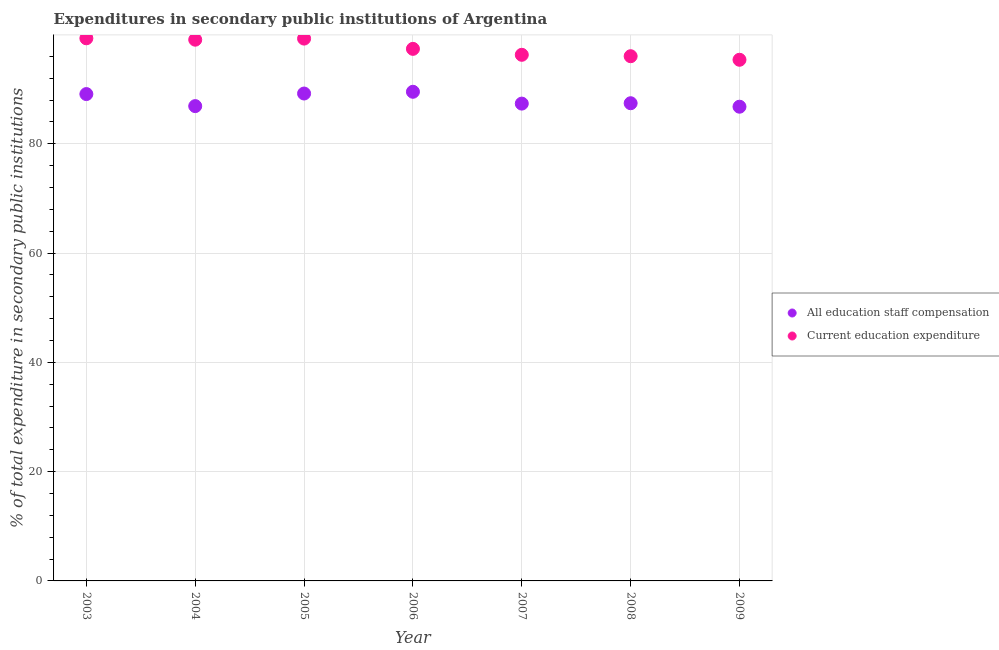How many different coloured dotlines are there?
Provide a short and direct response. 2. What is the expenditure in education in 2003?
Offer a very short reply. 99.31. Across all years, what is the maximum expenditure in staff compensation?
Your response must be concise. 89.52. Across all years, what is the minimum expenditure in education?
Make the answer very short. 95.38. What is the total expenditure in education in the graph?
Ensure brevity in your answer.  682.71. What is the difference between the expenditure in education in 2008 and that in 2009?
Your response must be concise. 0.65. What is the difference between the expenditure in staff compensation in 2003 and the expenditure in education in 2009?
Your answer should be very brief. -6.28. What is the average expenditure in staff compensation per year?
Offer a very short reply. 88.04. In the year 2005, what is the difference between the expenditure in staff compensation and expenditure in education?
Provide a short and direct response. -10.05. What is the ratio of the expenditure in staff compensation in 2005 to that in 2008?
Provide a short and direct response. 1.02. Is the difference between the expenditure in staff compensation in 2004 and 2007 greater than the difference between the expenditure in education in 2004 and 2007?
Your answer should be compact. No. What is the difference between the highest and the second highest expenditure in education?
Provide a succinct answer. 0.05. What is the difference between the highest and the lowest expenditure in staff compensation?
Keep it short and to the point. 2.73. Is the expenditure in education strictly greater than the expenditure in staff compensation over the years?
Offer a very short reply. Yes. Is the expenditure in staff compensation strictly less than the expenditure in education over the years?
Keep it short and to the point. Yes. How many dotlines are there?
Your answer should be very brief. 2. Are the values on the major ticks of Y-axis written in scientific E-notation?
Give a very brief answer. No. How are the legend labels stacked?
Your answer should be compact. Vertical. What is the title of the graph?
Offer a very short reply. Expenditures in secondary public institutions of Argentina. Does "Chemicals" appear as one of the legend labels in the graph?
Provide a short and direct response. No. What is the label or title of the X-axis?
Provide a short and direct response. Year. What is the label or title of the Y-axis?
Provide a short and direct response. % of total expenditure in secondary public institutions. What is the % of total expenditure in secondary public institutions in All education staff compensation in 2003?
Keep it short and to the point. 89.1. What is the % of total expenditure in secondary public institutions of Current education expenditure in 2003?
Your answer should be compact. 99.31. What is the % of total expenditure in secondary public institutions of All education staff compensation in 2004?
Keep it short and to the point. 86.9. What is the % of total expenditure in secondary public institutions in Current education expenditure in 2004?
Ensure brevity in your answer.  99.06. What is the % of total expenditure in secondary public institutions of All education staff compensation in 2005?
Make the answer very short. 89.2. What is the % of total expenditure in secondary public institutions in Current education expenditure in 2005?
Your response must be concise. 99.26. What is the % of total expenditure in secondary public institutions in All education staff compensation in 2006?
Your response must be concise. 89.52. What is the % of total expenditure in secondary public institutions in Current education expenditure in 2006?
Provide a short and direct response. 97.38. What is the % of total expenditure in secondary public institutions of All education staff compensation in 2007?
Offer a very short reply. 87.36. What is the % of total expenditure in secondary public institutions of Current education expenditure in 2007?
Keep it short and to the point. 96.29. What is the % of total expenditure in secondary public institutions in All education staff compensation in 2008?
Offer a terse response. 87.43. What is the % of total expenditure in secondary public institutions in Current education expenditure in 2008?
Your response must be concise. 96.03. What is the % of total expenditure in secondary public institutions in All education staff compensation in 2009?
Give a very brief answer. 86.79. What is the % of total expenditure in secondary public institutions of Current education expenditure in 2009?
Provide a short and direct response. 95.38. Across all years, what is the maximum % of total expenditure in secondary public institutions in All education staff compensation?
Give a very brief answer. 89.52. Across all years, what is the maximum % of total expenditure in secondary public institutions of Current education expenditure?
Make the answer very short. 99.31. Across all years, what is the minimum % of total expenditure in secondary public institutions of All education staff compensation?
Give a very brief answer. 86.79. Across all years, what is the minimum % of total expenditure in secondary public institutions in Current education expenditure?
Offer a very short reply. 95.38. What is the total % of total expenditure in secondary public institutions in All education staff compensation in the graph?
Ensure brevity in your answer.  616.31. What is the total % of total expenditure in secondary public institutions of Current education expenditure in the graph?
Make the answer very short. 682.71. What is the difference between the % of total expenditure in secondary public institutions of All education staff compensation in 2003 and that in 2004?
Offer a terse response. 2.2. What is the difference between the % of total expenditure in secondary public institutions of Current education expenditure in 2003 and that in 2004?
Offer a very short reply. 0.26. What is the difference between the % of total expenditure in secondary public institutions in All education staff compensation in 2003 and that in 2005?
Your answer should be compact. -0.1. What is the difference between the % of total expenditure in secondary public institutions in Current education expenditure in 2003 and that in 2005?
Provide a short and direct response. 0.05. What is the difference between the % of total expenditure in secondary public institutions of All education staff compensation in 2003 and that in 2006?
Provide a short and direct response. -0.42. What is the difference between the % of total expenditure in secondary public institutions of Current education expenditure in 2003 and that in 2006?
Your response must be concise. 1.93. What is the difference between the % of total expenditure in secondary public institutions of All education staff compensation in 2003 and that in 2007?
Ensure brevity in your answer.  1.75. What is the difference between the % of total expenditure in secondary public institutions of Current education expenditure in 2003 and that in 2007?
Ensure brevity in your answer.  3.02. What is the difference between the % of total expenditure in secondary public institutions in All education staff compensation in 2003 and that in 2008?
Your answer should be very brief. 1.68. What is the difference between the % of total expenditure in secondary public institutions in Current education expenditure in 2003 and that in 2008?
Provide a short and direct response. 3.28. What is the difference between the % of total expenditure in secondary public institutions of All education staff compensation in 2003 and that in 2009?
Make the answer very short. 2.31. What is the difference between the % of total expenditure in secondary public institutions in Current education expenditure in 2003 and that in 2009?
Your answer should be compact. 3.93. What is the difference between the % of total expenditure in secondary public institutions in All education staff compensation in 2004 and that in 2005?
Your response must be concise. -2.3. What is the difference between the % of total expenditure in secondary public institutions of Current education expenditure in 2004 and that in 2005?
Keep it short and to the point. -0.2. What is the difference between the % of total expenditure in secondary public institutions in All education staff compensation in 2004 and that in 2006?
Your response must be concise. -2.62. What is the difference between the % of total expenditure in secondary public institutions in Current education expenditure in 2004 and that in 2006?
Offer a very short reply. 1.68. What is the difference between the % of total expenditure in secondary public institutions in All education staff compensation in 2004 and that in 2007?
Make the answer very short. -0.46. What is the difference between the % of total expenditure in secondary public institutions of Current education expenditure in 2004 and that in 2007?
Give a very brief answer. 2.77. What is the difference between the % of total expenditure in secondary public institutions in All education staff compensation in 2004 and that in 2008?
Make the answer very short. -0.53. What is the difference between the % of total expenditure in secondary public institutions of Current education expenditure in 2004 and that in 2008?
Your answer should be compact. 3.02. What is the difference between the % of total expenditure in secondary public institutions in All education staff compensation in 2004 and that in 2009?
Your answer should be very brief. 0.11. What is the difference between the % of total expenditure in secondary public institutions of Current education expenditure in 2004 and that in 2009?
Offer a very short reply. 3.67. What is the difference between the % of total expenditure in secondary public institutions in All education staff compensation in 2005 and that in 2006?
Keep it short and to the point. -0.32. What is the difference between the % of total expenditure in secondary public institutions of Current education expenditure in 2005 and that in 2006?
Offer a very short reply. 1.88. What is the difference between the % of total expenditure in secondary public institutions in All education staff compensation in 2005 and that in 2007?
Offer a terse response. 1.85. What is the difference between the % of total expenditure in secondary public institutions in Current education expenditure in 2005 and that in 2007?
Provide a succinct answer. 2.97. What is the difference between the % of total expenditure in secondary public institutions of All education staff compensation in 2005 and that in 2008?
Provide a short and direct response. 1.78. What is the difference between the % of total expenditure in secondary public institutions of Current education expenditure in 2005 and that in 2008?
Make the answer very short. 3.23. What is the difference between the % of total expenditure in secondary public institutions of All education staff compensation in 2005 and that in 2009?
Provide a short and direct response. 2.41. What is the difference between the % of total expenditure in secondary public institutions of Current education expenditure in 2005 and that in 2009?
Ensure brevity in your answer.  3.88. What is the difference between the % of total expenditure in secondary public institutions of All education staff compensation in 2006 and that in 2007?
Give a very brief answer. 2.16. What is the difference between the % of total expenditure in secondary public institutions in Current education expenditure in 2006 and that in 2007?
Keep it short and to the point. 1.09. What is the difference between the % of total expenditure in secondary public institutions of All education staff compensation in 2006 and that in 2008?
Offer a very short reply. 2.1. What is the difference between the % of total expenditure in secondary public institutions in Current education expenditure in 2006 and that in 2008?
Offer a terse response. 1.35. What is the difference between the % of total expenditure in secondary public institutions of All education staff compensation in 2006 and that in 2009?
Make the answer very short. 2.73. What is the difference between the % of total expenditure in secondary public institutions of Current education expenditure in 2006 and that in 2009?
Keep it short and to the point. 2. What is the difference between the % of total expenditure in secondary public institutions in All education staff compensation in 2007 and that in 2008?
Your answer should be compact. -0.07. What is the difference between the % of total expenditure in secondary public institutions of Current education expenditure in 2007 and that in 2008?
Keep it short and to the point. 0.26. What is the difference between the % of total expenditure in secondary public institutions of All education staff compensation in 2007 and that in 2009?
Offer a very short reply. 0.57. What is the difference between the % of total expenditure in secondary public institutions of Current education expenditure in 2007 and that in 2009?
Ensure brevity in your answer.  0.91. What is the difference between the % of total expenditure in secondary public institutions of All education staff compensation in 2008 and that in 2009?
Offer a very short reply. 0.64. What is the difference between the % of total expenditure in secondary public institutions of Current education expenditure in 2008 and that in 2009?
Provide a succinct answer. 0.65. What is the difference between the % of total expenditure in secondary public institutions in All education staff compensation in 2003 and the % of total expenditure in secondary public institutions in Current education expenditure in 2004?
Your answer should be compact. -9.95. What is the difference between the % of total expenditure in secondary public institutions of All education staff compensation in 2003 and the % of total expenditure in secondary public institutions of Current education expenditure in 2005?
Provide a succinct answer. -10.15. What is the difference between the % of total expenditure in secondary public institutions in All education staff compensation in 2003 and the % of total expenditure in secondary public institutions in Current education expenditure in 2006?
Offer a terse response. -8.27. What is the difference between the % of total expenditure in secondary public institutions of All education staff compensation in 2003 and the % of total expenditure in secondary public institutions of Current education expenditure in 2007?
Your answer should be compact. -7.19. What is the difference between the % of total expenditure in secondary public institutions in All education staff compensation in 2003 and the % of total expenditure in secondary public institutions in Current education expenditure in 2008?
Provide a short and direct response. -6.93. What is the difference between the % of total expenditure in secondary public institutions of All education staff compensation in 2003 and the % of total expenditure in secondary public institutions of Current education expenditure in 2009?
Make the answer very short. -6.28. What is the difference between the % of total expenditure in secondary public institutions in All education staff compensation in 2004 and the % of total expenditure in secondary public institutions in Current education expenditure in 2005?
Give a very brief answer. -12.36. What is the difference between the % of total expenditure in secondary public institutions in All education staff compensation in 2004 and the % of total expenditure in secondary public institutions in Current education expenditure in 2006?
Make the answer very short. -10.48. What is the difference between the % of total expenditure in secondary public institutions of All education staff compensation in 2004 and the % of total expenditure in secondary public institutions of Current education expenditure in 2007?
Keep it short and to the point. -9.39. What is the difference between the % of total expenditure in secondary public institutions in All education staff compensation in 2004 and the % of total expenditure in secondary public institutions in Current education expenditure in 2008?
Offer a very short reply. -9.13. What is the difference between the % of total expenditure in secondary public institutions of All education staff compensation in 2004 and the % of total expenditure in secondary public institutions of Current education expenditure in 2009?
Give a very brief answer. -8.48. What is the difference between the % of total expenditure in secondary public institutions of All education staff compensation in 2005 and the % of total expenditure in secondary public institutions of Current education expenditure in 2006?
Provide a succinct answer. -8.17. What is the difference between the % of total expenditure in secondary public institutions of All education staff compensation in 2005 and the % of total expenditure in secondary public institutions of Current education expenditure in 2007?
Offer a very short reply. -7.09. What is the difference between the % of total expenditure in secondary public institutions of All education staff compensation in 2005 and the % of total expenditure in secondary public institutions of Current education expenditure in 2008?
Your answer should be compact. -6.83. What is the difference between the % of total expenditure in secondary public institutions in All education staff compensation in 2005 and the % of total expenditure in secondary public institutions in Current education expenditure in 2009?
Offer a very short reply. -6.18. What is the difference between the % of total expenditure in secondary public institutions of All education staff compensation in 2006 and the % of total expenditure in secondary public institutions of Current education expenditure in 2007?
Offer a terse response. -6.77. What is the difference between the % of total expenditure in secondary public institutions in All education staff compensation in 2006 and the % of total expenditure in secondary public institutions in Current education expenditure in 2008?
Your response must be concise. -6.51. What is the difference between the % of total expenditure in secondary public institutions in All education staff compensation in 2006 and the % of total expenditure in secondary public institutions in Current education expenditure in 2009?
Ensure brevity in your answer.  -5.86. What is the difference between the % of total expenditure in secondary public institutions of All education staff compensation in 2007 and the % of total expenditure in secondary public institutions of Current education expenditure in 2008?
Provide a succinct answer. -8.67. What is the difference between the % of total expenditure in secondary public institutions in All education staff compensation in 2007 and the % of total expenditure in secondary public institutions in Current education expenditure in 2009?
Give a very brief answer. -8.02. What is the difference between the % of total expenditure in secondary public institutions of All education staff compensation in 2008 and the % of total expenditure in secondary public institutions of Current education expenditure in 2009?
Your answer should be compact. -7.96. What is the average % of total expenditure in secondary public institutions in All education staff compensation per year?
Keep it short and to the point. 88.04. What is the average % of total expenditure in secondary public institutions in Current education expenditure per year?
Keep it short and to the point. 97.53. In the year 2003, what is the difference between the % of total expenditure in secondary public institutions of All education staff compensation and % of total expenditure in secondary public institutions of Current education expenditure?
Your answer should be very brief. -10.21. In the year 2004, what is the difference between the % of total expenditure in secondary public institutions of All education staff compensation and % of total expenditure in secondary public institutions of Current education expenditure?
Ensure brevity in your answer.  -12.16. In the year 2005, what is the difference between the % of total expenditure in secondary public institutions of All education staff compensation and % of total expenditure in secondary public institutions of Current education expenditure?
Give a very brief answer. -10.05. In the year 2006, what is the difference between the % of total expenditure in secondary public institutions of All education staff compensation and % of total expenditure in secondary public institutions of Current education expenditure?
Keep it short and to the point. -7.86. In the year 2007, what is the difference between the % of total expenditure in secondary public institutions of All education staff compensation and % of total expenditure in secondary public institutions of Current education expenditure?
Your answer should be very brief. -8.93. In the year 2008, what is the difference between the % of total expenditure in secondary public institutions of All education staff compensation and % of total expenditure in secondary public institutions of Current education expenditure?
Your answer should be compact. -8.61. In the year 2009, what is the difference between the % of total expenditure in secondary public institutions of All education staff compensation and % of total expenditure in secondary public institutions of Current education expenditure?
Provide a succinct answer. -8.59. What is the ratio of the % of total expenditure in secondary public institutions in All education staff compensation in 2003 to that in 2004?
Offer a terse response. 1.03. What is the ratio of the % of total expenditure in secondary public institutions of All education staff compensation in 2003 to that in 2005?
Provide a succinct answer. 1. What is the ratio of the % of total expenditure in secondary public institutions of All education staff compensation in 2003 to that in 2006?
Your response must be concise. 1. What is the ratio of the % of total expenditure in secondary public institutions in Current education expenditure in 2003 to that in 2006?
Offer a terse response. 1.02. What is the ratio of the % of total expenditure in secondary public institutions of All education staff compensation in 2003 to that in 2007?
Provide a short and direct response. 1.02. What is the ratio of the % of total expenditure in secondary public institutions in Current education expenditure in 2003 to that in 2007?
Keep it short and to the point. 1.03. What is the ratio of the % of total expenditure in secondary public institutions of All education staff compensation in 2003 to that in 2008?
Ensure brevity in your answer.  1.02. What is the ratio of the % of total expenditure in secondary public institutions in Current education expenditure in 2003 to that in 2008?
Offer a very short reply. 1.03. What is the ratio of the % of total expenditure in secondary public institutions in All education staff compensation in 2003 to that in 2009?
Give a very brief answer. 1.03. What is the ratio of the % of total expenditure in secondary public institutions of Current education expenditure in 2003 to that in 2009?
Your answer should be very brief. 1.04. What is the ratio of the % of total expenditure in secondary public institutions in All education staff compensation in 2004 to that in 2005?
Ensure brevity in your answer.  0.97. What is the ratio of the % of total expenditure in secondary public institutions of Current education expenditure in 2004 to that in 2005?
Your answer should be very brief. 1. What is the ratio of the % of total expenditure in secondary public institutions in All education staff compensation in 2004 to that in 2006?
Provide a succinct answer. 0.97. What is the ratio of the % of total expenditure in secondary public institutions of Current education expenditure in 2004 to that in 2006?
Offer a terse response. 1.02. What is the ratio of the % of total expenditure in secondary public institutions in Current education expenditure in 2004 to that in 2007?
Make the answer very short. 1.03. What is the ratio of the % of total expenditure in secondary public institutions in All education staff compensation in 2004 to that in 2008?
Ensure brevity in your answer.  0.99. What is the ratio of the % of total expenditure in secondary public institutions of Current education expenditure in 2004 to that in 2008?
Your answer should be compact. 1.03. What is the ratio of the % of total expenditure in secondary public institutions of All education staff compensation in 2004 to that in 2009?
Provide a short and direct response. 1. What is the ratio of the % of total expenditure in secondary public institutions of Current education expenditure in 2005 to that in 2006?
Make the answer very short. 1.02. What is the ratio of the % of total expenditure in secondary public institutions in All education staff compensation in 2005 to that in 2007?
Offer a very short reply. 1.02. What is the ratio of the % of total expenditure in secondary public institutions in Current education expenditure in 2005 to that in 2007?
Your answer should be very brief. 1.03. What is the ratio of the % of total expenditure in secondary public institutions in All education staff compensation in 2005 to that in 2008?
Give a very brief answer. 1.02. What is the ratio of the % of total expenditure in secondary public institutions of Current education expenditure in 2005 to that in 2008?
Offer a very short reply. 1.03. What is the ratio of the % of total expenditure in secondary public institutions in All education staff compensation in 2005 to that in 2009?
Offer a very short reply. 1.03. What is the ratio of the % of total expenditure in secondary public institutions in Current education expenditure in 2005 to that in 2009?
Keep it short and to the point. 1.04. What is the ratio of the % of total expenditure in secondary public institutions of All education staff compensation in 2006 to that in 2007?
Give a very brief answer. 1.02. What is the ratio of the % of total expenditure in secondary public institutions of Current education expenditure in 2006 to that in 2007?
Make the answer very short. 1.01. What is the ratio of the % of total expenditure in secondary public institutions of Current education expenditure in 2006 to that in 2008?
Give a very brief answer. 1.01. What is the ratio of the % of total expenditure in secondary public institutions of All education staff compensation in 2006 to that in 2009?
Your answer should be very brief. 1.03. What is the ratio of the % of total expenditure in secondary public institutions of Current education expenditure in 2006 to that in 2009?
Keep it short and to the point. 1.02. What is the ratio of the % of total expenditure in secondary public institutions in Current education expenditure in 2007 to that in 2008?
Offer a terse response. 1. What is the ratio of the % of total expenditure in secondary public institutions of All education staff compensation in 2007 to that in 2009?
Provide a short and direct response. 1.01. What is the ratio of the % of total expenditure in secondary public institutions in Current education expenditure in 2007 to that in 2009?
Your response must be concise. 1.01. What is the ratio of the % of total expenditure in secondary public institutions of All education staff compensation in 2008 to that in 2009?
Your answer should be very brief. 1.01. What is the ratio of the % of total expenditure in secondary public institutions in Current education expenditure in 2008 to that in 2009?
Your answer should be compact. 1.01. What is the difference between the highest and the second highest % of total expenditure in secondary public institutions in All education staff compensation?
Offer a terse response. 0.32. What is the difference between the highest and the second highest % of total expenditure in secondary public institutions of Current education expenditure?
Give a very brief answer. 0.05. What is the difference between the highest and the lowest % of total expenditure in secondary public institutions in All education staff compensation?
Ensure brevity in your answer.  2.73. What is the difference between the highest and the lowest % of total expenditure in secondary public institutions of Current education expenditure?
Give a very brief answer. 3.93. 